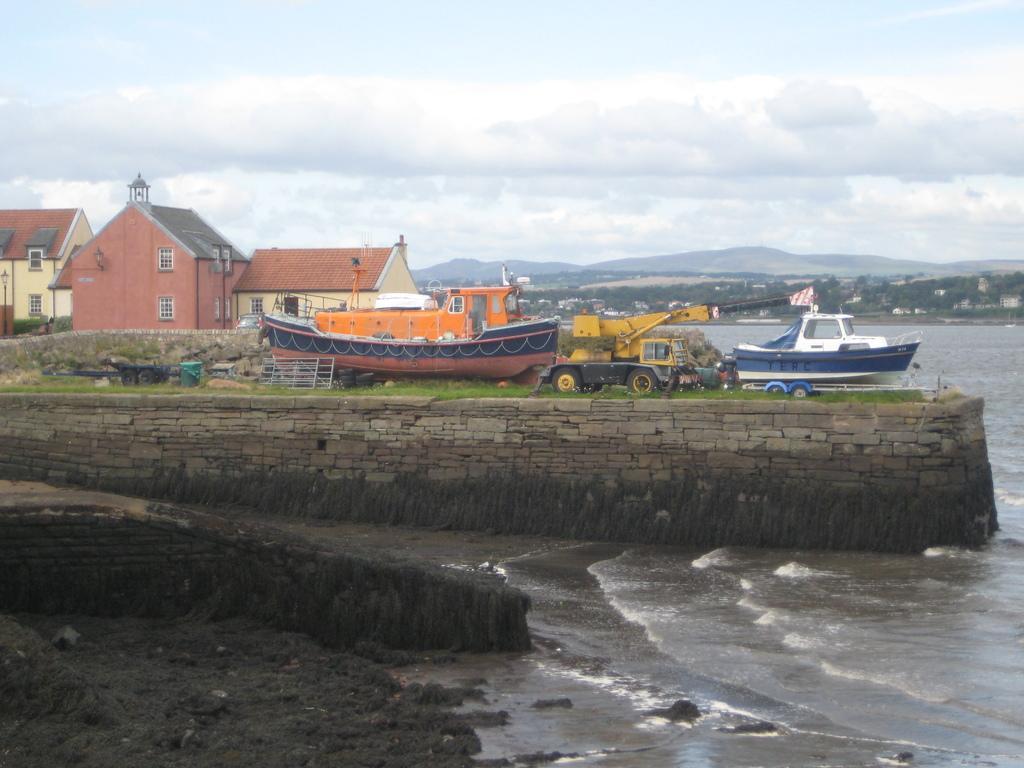In one or two sentences, can you explain what this image depicts? In the foreground of this image, there is mud, water and two tiny walls. One on one wall, there is grass. In the background, there are two ships, a vehicle, an object having Tyre, a basket, few houses, trees, mountains, water, sky and the cloud. 